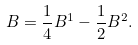<formula> <loc_0><loc_0><loc_500><loc_500>B = { \frac { 1 } { 4 } B ^ { 1 } - \frac { 1 } { 2 } B ^ { 2 } } .</formula> 